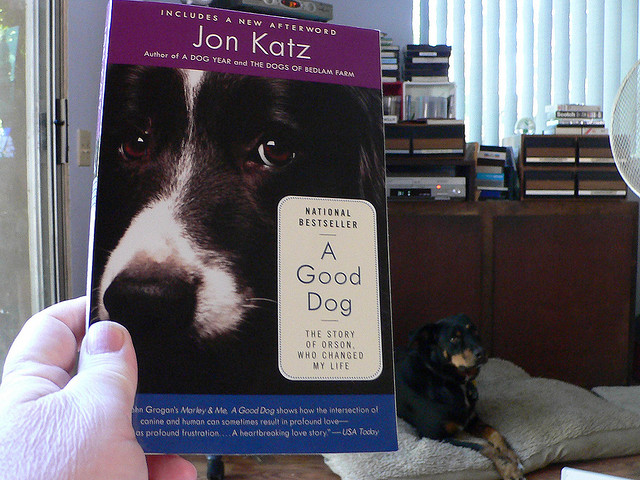Can you describe the dog on the couch? The dog on the couch is a small, black and brown canine, seemingly a breed mix. It is comfortably lying down, looking relaxed, perhaps observing the book or its owner casually. 